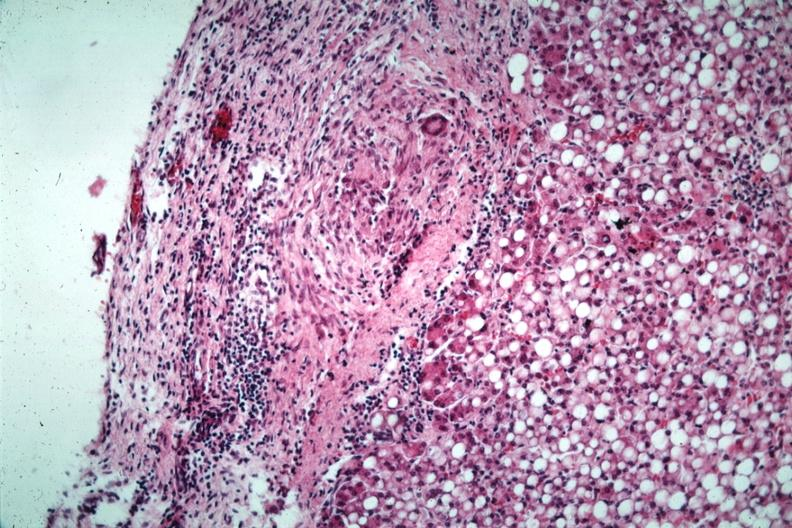what is present?
Answer the question using a single word or phrase. Tuberculous peritonitis 